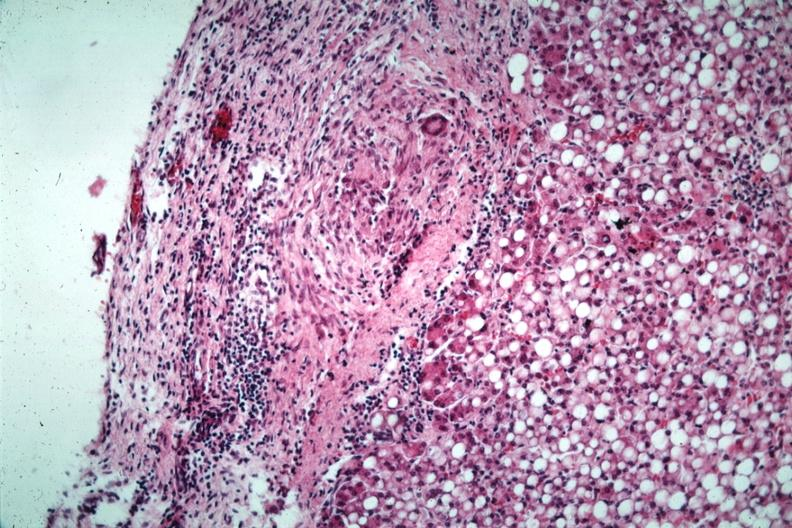what is present?
Answer the question using a single word or phrase. Tuberculous peritonitis 